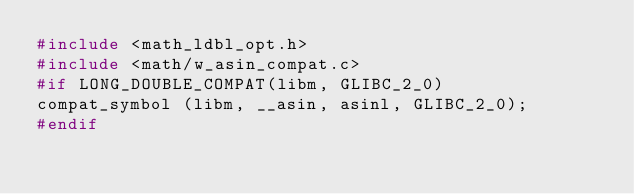<code> <loc_0><loc_0><loc_500><loc_500><_C_>#include <math_ldbl_opt.h>
#include <math/w_asin_compat.c>
#if LONG_DOUBLE_COMPAT(libm, GLIBC_2_0)
compat_symbol (libm, __asin, asinl, GLIBC_2_0);
#endif
</code> 